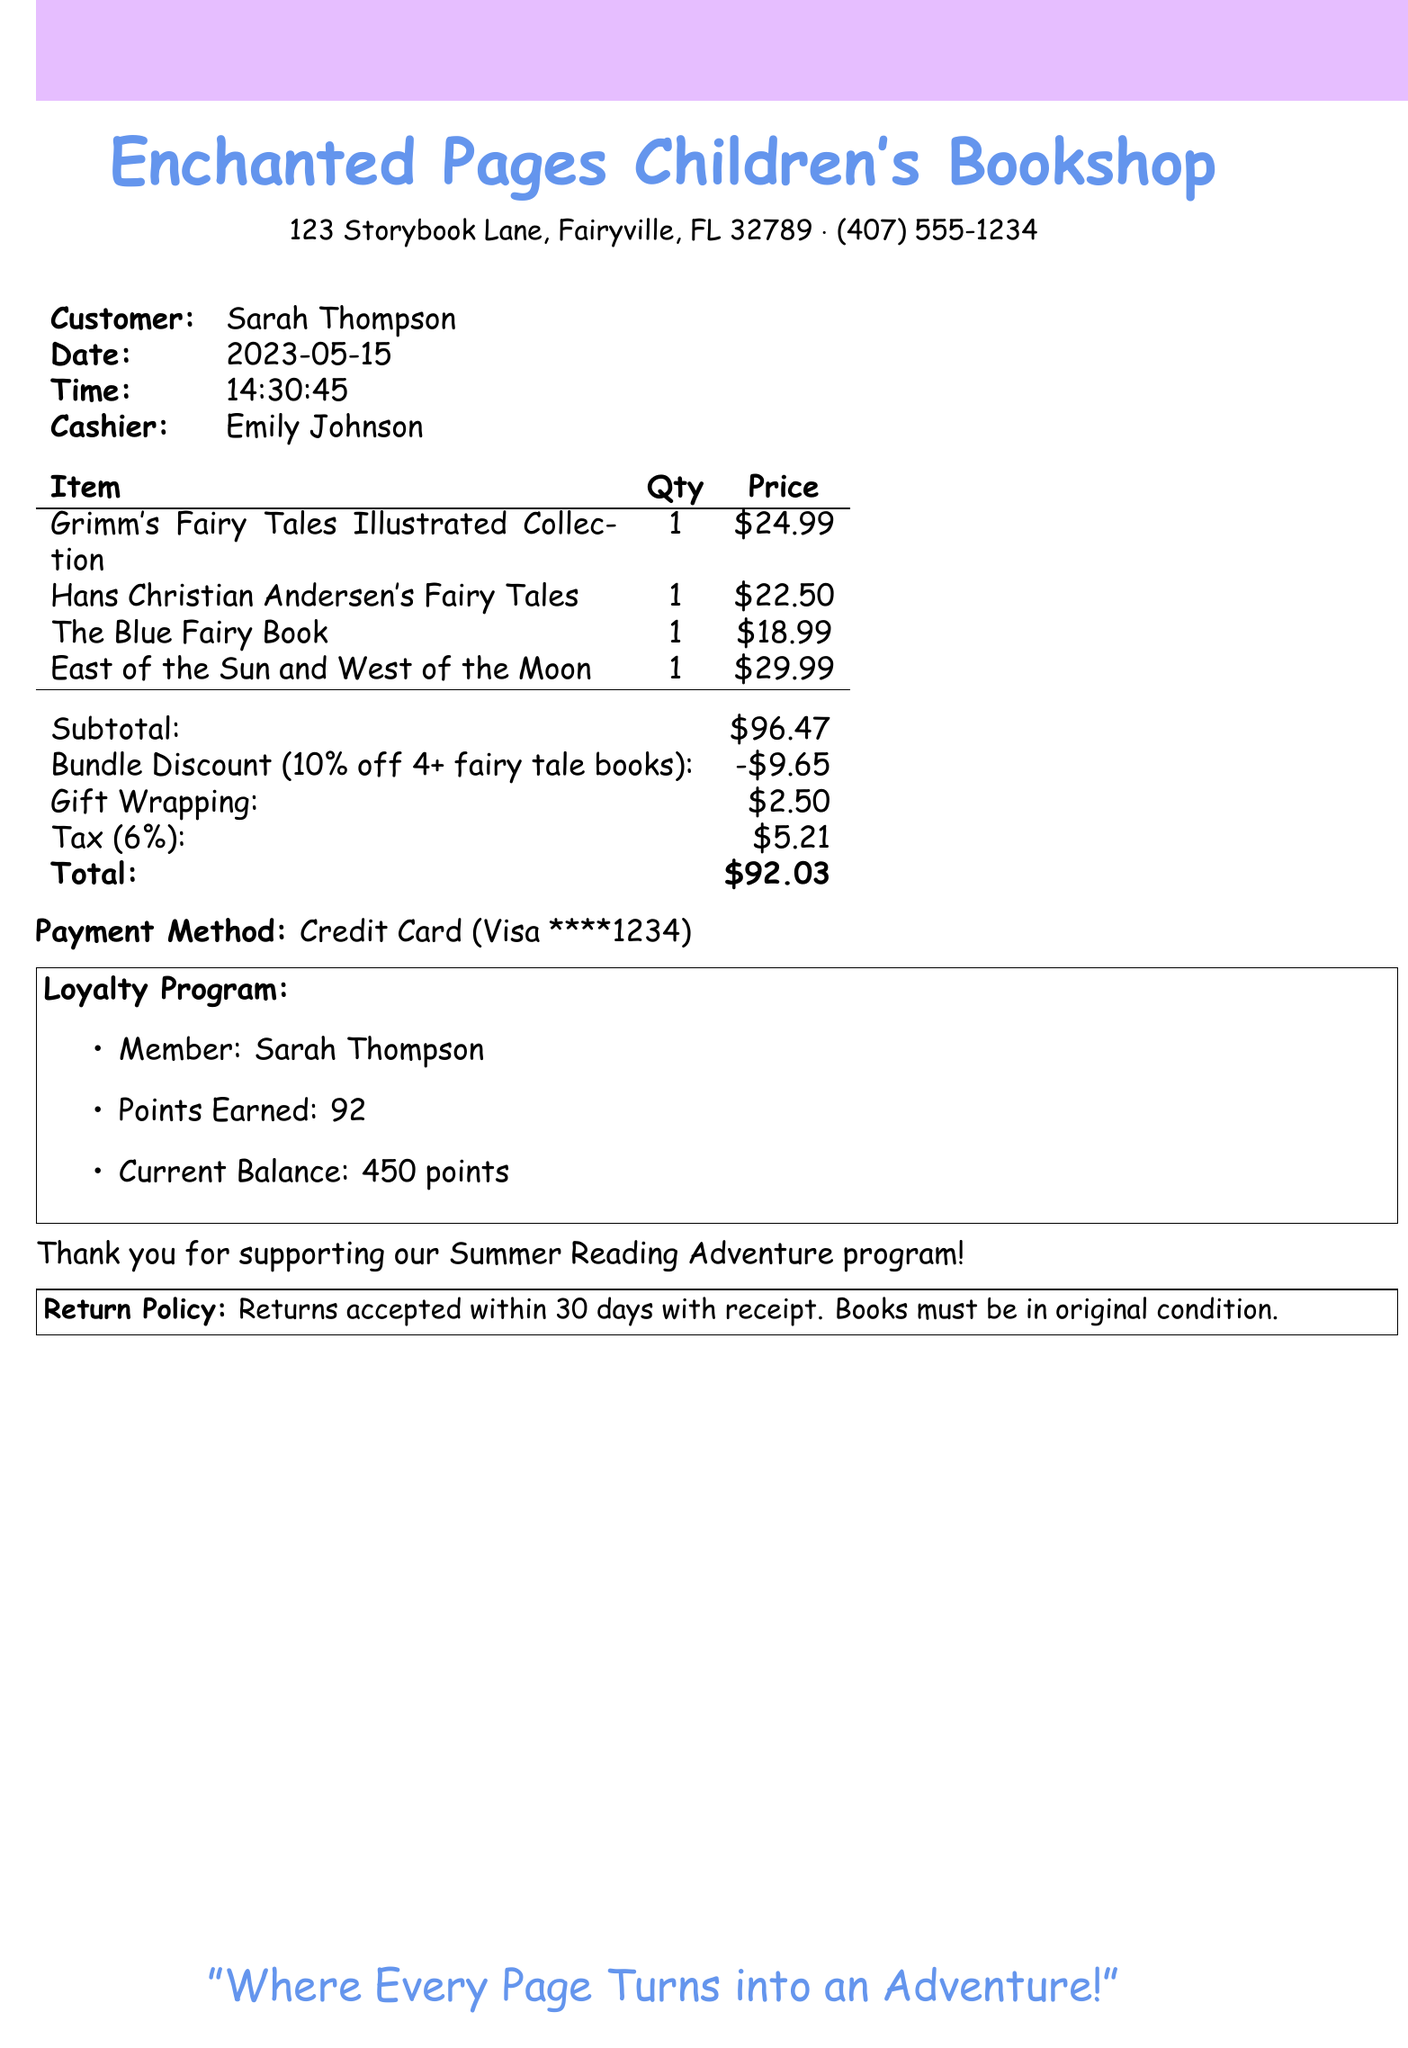What is the customer name? The customer's name is shown in the document under the customer section.
Answer: Sarah Thompson What is the transaction date? The date of the transaction is mentioned in the document.
Answer: 2023-05-15 How many fairy tale books were purchased? The number of books can be inferred from the transaction details.
Answer: 4 What is the subtotal amount? The subtotal is clearly listed in the financial summary of the document.
Answer: $96.47 What type of discount was applied? The type of discount is noted in the discount section of the document.
Answer: Bundle Discount What is the total amount after calculations? The final amount is shown as the total at the end of the financial summary.
Answer: $92.03 How much was earned in loyalty points? The points earned are specified in the loyalty program section of the document.
Answer: 92 What was the gift wrapping cost? The cost for gift wrapping is included in the financial breakdown of the document.
Answer: $2.50 Who was the cashier for this transaction? The cashier's name is mentioned in the transaction details.
Answer: Emily Johnson 